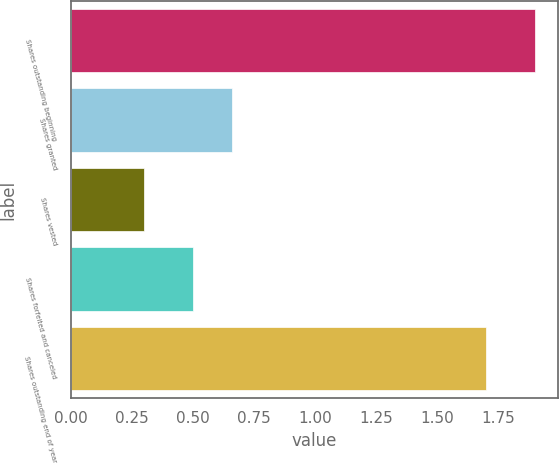Convert chart. <chart><loc_0><loc_0><loc_500><loc_500><bar_chart><fcel>Shares outstanding beginning<fcel>Shares granted<fcel>Shares vested<fcel>Shares forfeited and canceled<fcel>Shares outstanding end of year<nl><fcel>1.9<fcel>0.66<fcel>0.3<fcel>0.5<fcel>1.7<nl></chart> 